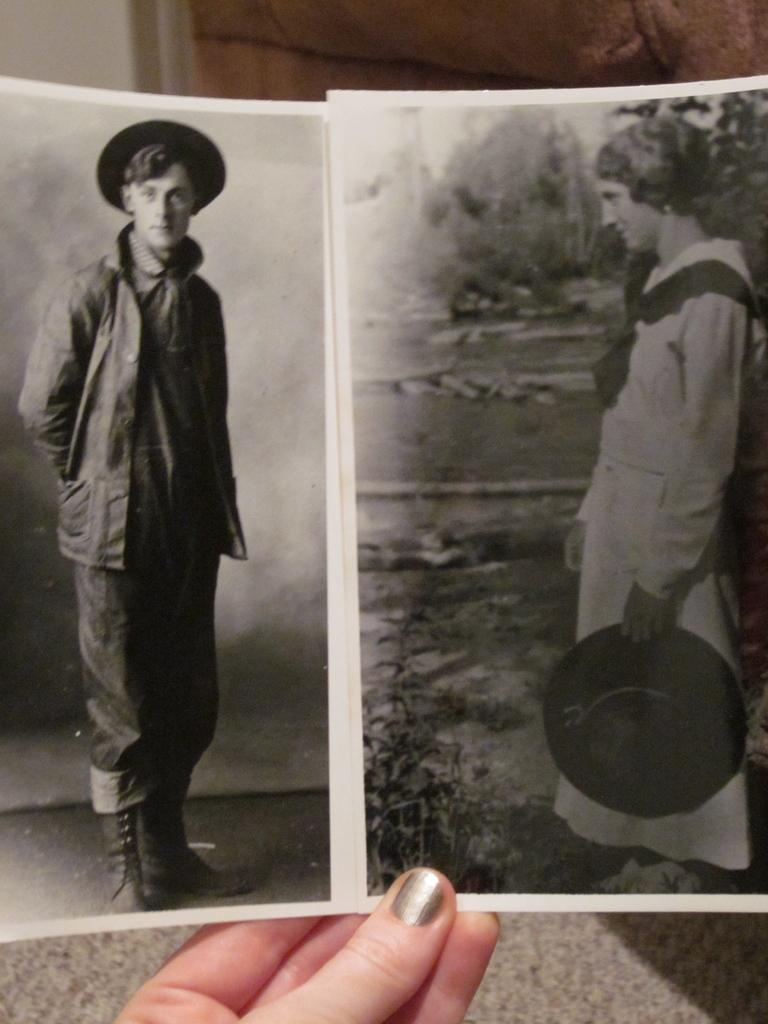What is the person holding in the image? The person is holding two black and white photographs in the image. What can be seen in the background of the image? There is a carpet and a wall in the background of the image. What type of throat condition can be seen in the image? There is no throat condition present in the image; it features a person holding two black and white photographs with a carpet and a wall in the background. 